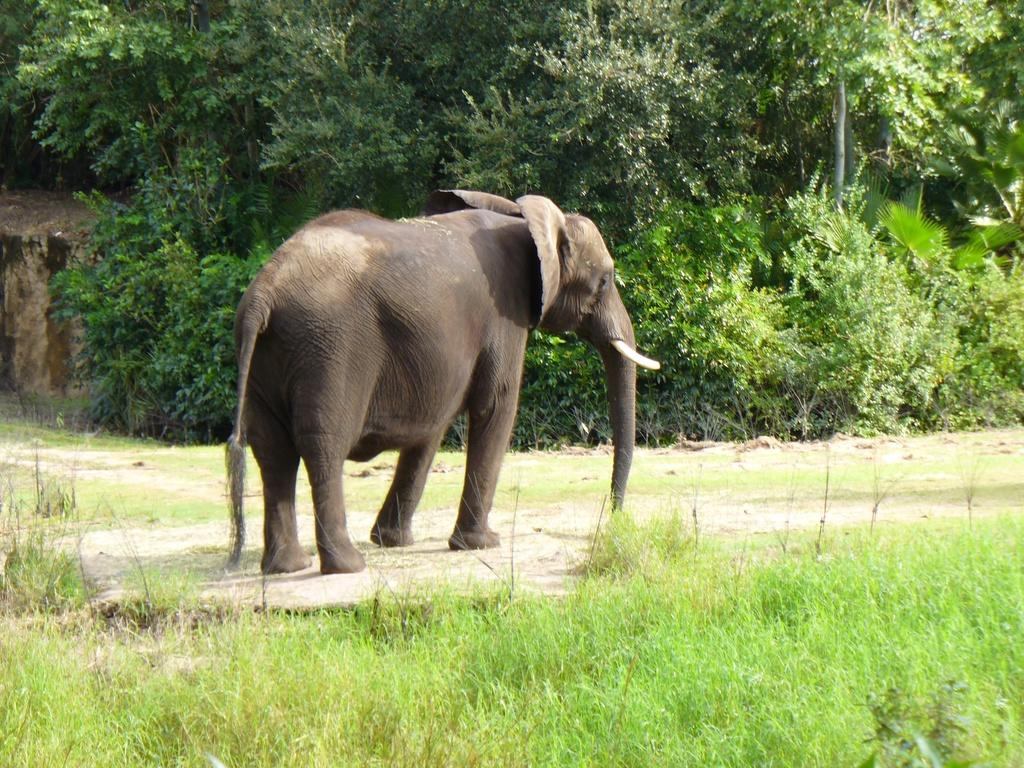What animal is present in the image? There is an elephant in the image. What type of vegetation is at the bottom of the image? There is grass at the bottom of the image. What can be seen in the background of the image? There are plants and trees in the background of the image. What type of plot is the elephant standing on in the image? There is no plot mentioned or visible in the image; it simply shows an elephant standing on grass. 